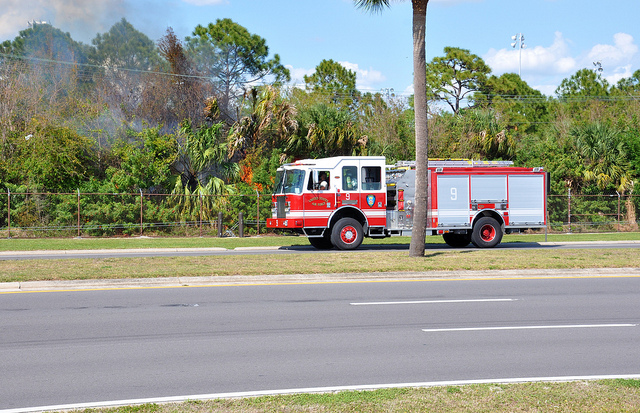Please identify all text content in this image. 9 9 